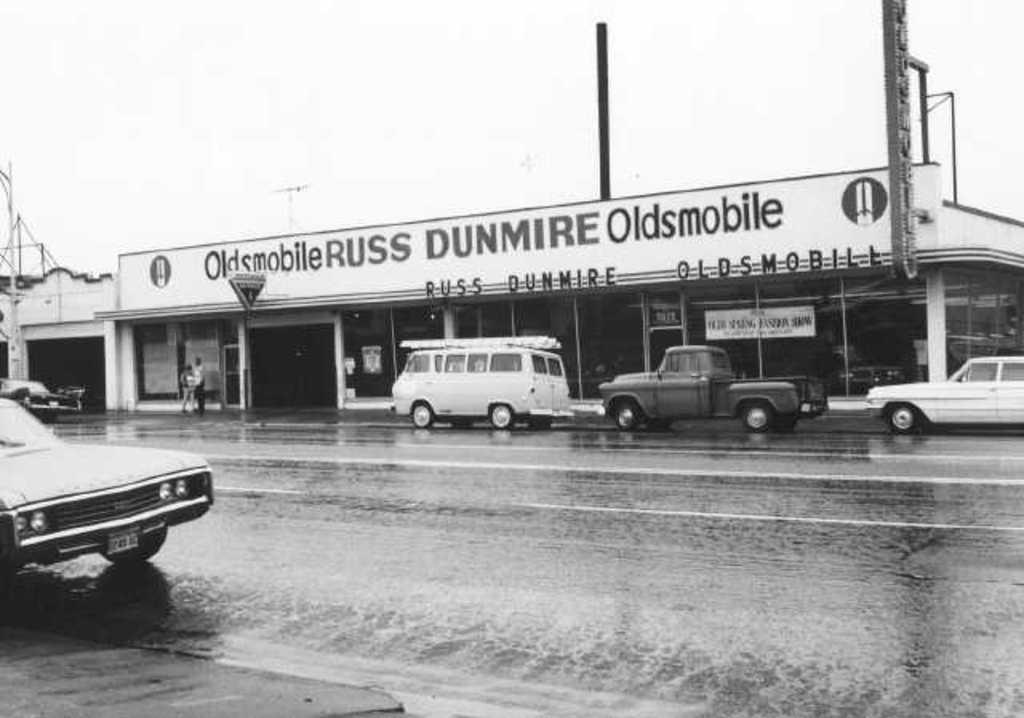What can be seen at the bottom of the image? The image shows a road at the bottom. What is present on the road in the image? There are many vehicles on the road in the image. What is located in the front of the image? There is a building in the front of the image with text on it. What is visible at the top of the image? The sky is visible at the top of the image. Can you tell me what type of vase is on the building in the image? There is no vase present on the building in the image. What fact can be learned about the vehicles in the image? The provided facts do not mention any specific facts about the vehicles in the image. 